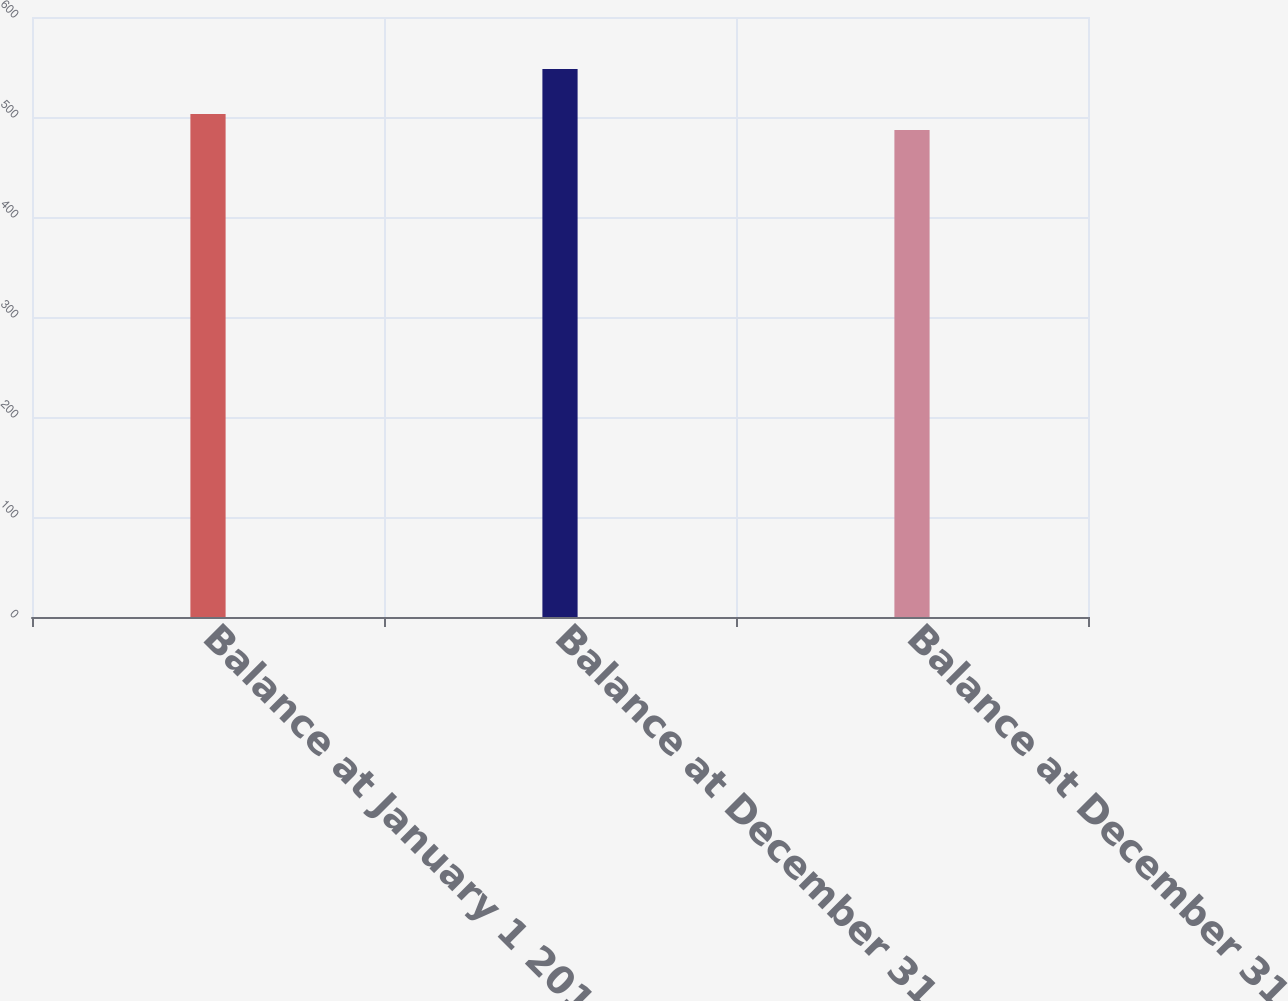<chart> <loc_0><loc_0><loc_500><loc_500><bar_chart><fcel>Balance at January 1 2016<fcel>Balance at December 31 2016<fcel>Balance at December 31 2017<nl><fcel>503<fcel>548<fcel>487<nl></chart> 